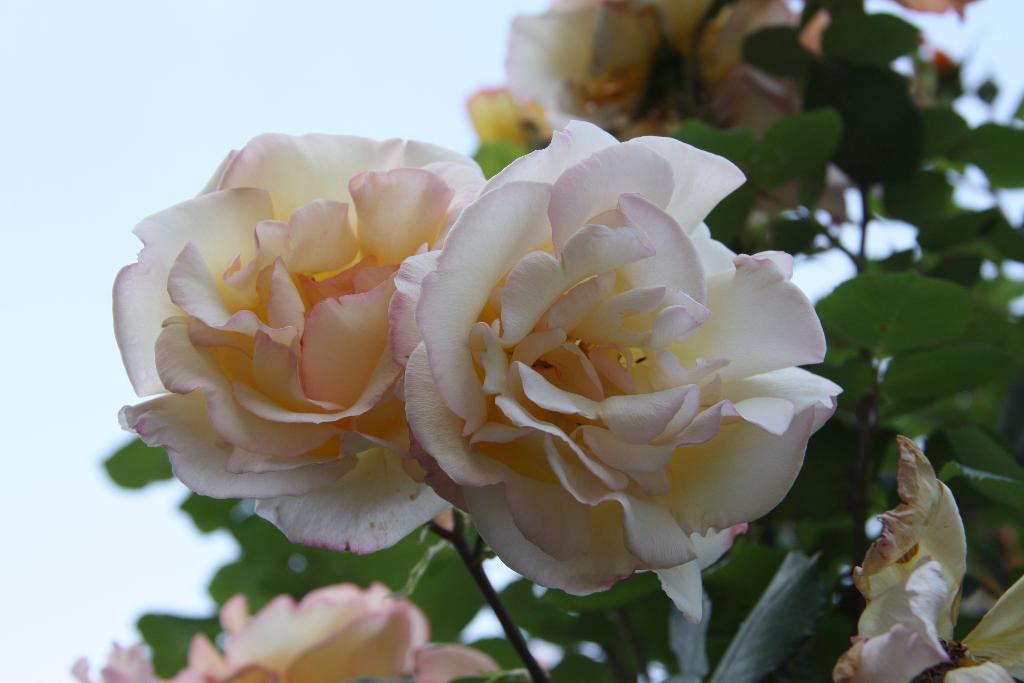What is present in the image? There is a flower in the image. Can you describe the color of the flower? The flower is white and light pale red in color. Are there any other parts of the plant visible in the image? Yes, there are leaves associated with the flower. What can be seen in the background of the image? The sky is visible in the image. What type of sidewalk can be seen surrounding the flower in the image? There is no sidewalk present in the image; it only features a flower and its leaves. Can you tell me how many boots are visible near the flower in the image? There are no boots present in the image. 